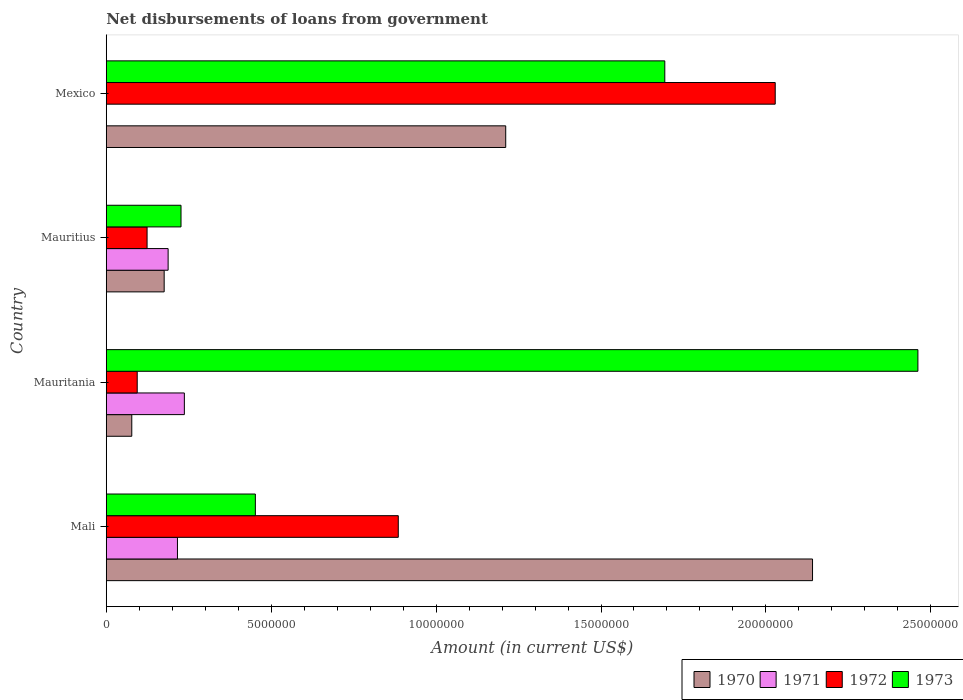How many different coloured bars are there?
Your answer should be compact. 4. Are the number of bars on each tick of the Y-axis equal?
Provide a succinct answer. No. How many bars are there on the 3rd tick from the top?
Ensure brevity in your answer.  4. How many bars are there on the 1st tick from the bottom?
Give a very brief answer. 4. What is the label of the 1st group of bars from the top?
Your response must be concise. Mexico. What is the amount of loan disbursed from government in 1973 in Mauritius?
Give a very brief answer. 2.27e+06. Across all countries, what is the maximum amount of loan disbursed from government in 1971?
Ensure brevity in your answer.  2.37e+06. Across all countries, what is the minimum amount of loan disbursed from government in 1972?
Your answer should be very brief. 9.39e+05. In which country was the amount of loan disbursed from government in 1972 maximum?
Your answer should be very brief. Mexico. What is the total amount of loan disbursed from government in 1973 in the graph?
Offer a terse response. 4.83e+07. What is the difference between the amount of loan disbursed from government in 1972 in Mauritania and that in Mexico?
Your response must be concise. -1.93e+07. What is the difference between the amount of loan disbursed from government in 1973 in Mauritania and the amount of loan disbursed from government in 1970 in Mexico?
Provide a succinct answer. 1.25e+07. What is the average amount of loan disbursed from government in 1973 per country?
Provide a succinct answer. 1.21e+07. What is the difference between the amount of loan disbursed from government in 1973 and amount of loan disbursed from government in 1972 in Mexico?
Give a very brief answer. -3.35e+06. What is the ratio of the amount of loan disbursed from government in 1972 in Mali to that in Mauritius?
Make the answer very short. 7.15. What is the difference between the highest and the second highest amount of loan disbursed from government in 1973?
Your answer should be compact. 7.67e+06. What is the difference between the highest and the lowest amount of loan disbursed from government in 1972?
Your response must be concise. 1.93e+07. In how many countries, is the amount of loan disbursed from government in 1973 greater than the average amount of loan disbursed from government in 1973 taken over all countries?
Offer a very short reply. 2. Is the sum of the amount of loan disbursed from government in 1972 in Mauritania and Mauritius greater than the maximum amount of loan disbursed from government in 1971 across all countries?
Make the answer very short. No. Is it the case that in every country, the sum of the amount of loan disbursed from government in 1970 and amount of loan disbursed from government in 1973 is greater than the amount of loan disbursed from government in 1971?
Offer a terse response. Yes. Are all the bars in the graph horizontal?
Provide a short and direct response. Yes. Are the values on the major ticks of X-axis written in scientific E-notation?
Provide a short and direct response. No. Does the graph contain grids?
Offer a very short reply. No. Where does the legend appear in the graph?
Provide a succinct answer. Bottom right. How many legend labels are there?
Provide a succinct answer. 4. How are the legend labels stacked?
Offer a terse response. Horizontal. What is the title of the graph?
Keep it short and to the point. Net disbursements of loans from government. Does "2012" appear as one of the legend labels in the graph?
Your answer should be compact. No. What is the Amount (in current US$) in 1970 in Mali?
Keep it short and to the point. 2.14e+07. What is the Amount (in current US$) in 1971 in Mali?
Give a very brief answer. 2.16e+06. What is the Amount (in current US$) in 1972 in Mali?
Give a very brief answer. 8.85e+06. What is the Amount (in current US$) of 1973 in Mali?
Provide a short and direct response. 4.52e+06. What is the Amount (in current US$) of 1970 in Mauritania?
Offer a terse response. 7.74e+05. What is the Amount (in current US$) of 1971 in Mauritania?
Make the answer very short. 2.37e+06. What is the Amount (in current US$) of 1972 in Mauritania?
Your answer should be compact. 9.39e+05. What is the Amount (in current US$) in 1973 in Mauritania?
Make the answer very short. 2.46e+07. What is the Amount (in current US$) in 1970 in Mauritius?
Make the answer very short. 1.76e+06. What is the Amount (in current US$) of 1971 in Mauritius?
Your answer should be very brief. 1.88e+06. What is the Amount (in current US$) in 1972 in Mauritius?
Give a very brief answer. 1.24e+06. What is the Amount (in current US$) of 1973 in Mauritius?
Give a very brief answer. 2.27e+06. What is the Amount (in current US$) in 1970 in Mexico?
Your answer should be very brief. 1.21e+07. What is the Amount (in current US$) in 1971 in Mexico?
Your response must be concise. 0. What is the Amount (in current US$) in 1972 in Mexico?
Offer a terse response. 2.03e+07. What is the Amount (in current US$) of 1973 in Mexico?
Provide a succinct answer. 1.69e+07. Across all countries, what is the maximum Amount (in current US$) in 1970?
Make the answer very short. 2.14e+07. Across all countries, what is the maximum Amount (in current US$) of 1971?
Your answer should be very brief. 2.37e+06. Across all countries, what is the maximum Amount (in current US$) of 1972?
Make the answer very short. 2.03e+07. Across all countries, what is the maximum Amount (in current US$) in 1973?
Keep it short and to the point. 2.46e+07. Across all countries, what is the minimum Amount (in current US$) in 1970?
Your response must be concise. 7.74e+05. Across all countries, what is the minimum Amount (in current US$) of 1971?
Provide a short and direct response. 0. Across all countries, what is the minimum Amount (in current US$) of 1972?
Your answer should be very brief. 9.39e+05. Across all countries, what is the minimum Amount (in current US$) of 1973?
Make the answer very short. 2.27e+06. What is the total Amount (in current US$) in 1970 in the graph?
Give a very brief answer. 3.61e+07. What is the total Amount (in current US$) in 1971 in the graph?
Give a very brief answer. 6.40e+06. What is the total Amount (in current US$) in 1972 in the graph?
Ensure brevity in your answer.  3.13e+07. What is the total Amount (in current US$) of 1973 in the graph?
Offer a very short reply. 4.83e+07. What is the difference between the Amount (in current US$) of 1970 in Mali and that in Mauritania?
Your answer should be very brief. 2.06e+07. What is the difference between the Amount (in current US$) in 1971 in Mali and that in Mauritania?
Keep it short and to the point. -2.09e+05. What is the difference between the Amount (in current US$) in 1972 in Mali and that in Mauritania?
Give a very brief answer. 7.92e+06. What is the difference between the Amount (in current US$) in 1973 in Mali and that in Mauritania?
Provide a short and direct response. -2.01e+07. What is the difference between the Amount (in current US$) in 1970 in Mali and that in Mauritius?
Keep it short and to the point. 1.97e+07. What is the difference between the Amount (in current US$) in 1971 in Mali and that in Mauritius?
Offer a terse response. 2.83e+05. What is the difference between the Amount (in current US$) in 1972 in Mali and that in Mauritius?
Give a very brief answer. 7.62e+06. What is the difference between the Amount (in current US$) in 1973 in Mali and that in Mauritius?
Provide a succinct answer. 2.25e+06. What is the difference between the Amount (in current US$) in 1970 in Mali and that in Mexico?
Offer a terse response. 9.30e+06. What is the difference between the Amount (in current US$) of 1972 in Mali and that in Mexico?
Provide a short and direct response. -1.14e+07. What is the difference between the Amount (in current US$) in 1973 in Mali and that in Mexico?
Offer a very short reply. -1.24e+07. What is the difference between the Amount (in current US$) of 1970 in Mauritania and that in Mauritius?
Ensure brevity in your answer.  -9.82e+05. What is the difference between the Amount (in current US$) of 1971 in Mauritania and that in Mauritius?
Give a very brief answer. 4.92e+05. What is the difference between the Amount (in current US$) of 1972 in Mauritania and that in Mauritius?
Offer a terse response. -2.99e+05. What is the difference between the Amount (in current US$) in 1973 in Mauritania and that in Mauritius?
Your answer should be compact. 2.23e+07. What is the difference between the Amount (in current US$) of 1970 in Mauritania and that in Mexico?
Offer a very short reply. -1.13e+07. What is the difference between the Amount (in current US$) in 1972 in Mauritania and that in Mexico?
Provide a short and direct response. -1.93e+07. What is the difference between the Amount (in current US$) of 1973 in Mauritania and that in Mexico?
Your answer should be very brief. 7.67e+06. What is the difference between the Amount (in current US$) of 1970 in Mauritius and that in Mexico?
Your response must be concise. -1.04e+07. What is the difference between the Amount (in current US$) of 1972 in Mauritius and that in Mexico?
Make the answer very short. -1.90e+07. What is the difference between the Amount (in current US$) in 1973 in Mauritius and that in Mexico?
Your response must be concise. -1.47e+07. What is the difference between the Amount (in current US$) in 1970 in Mali and the Amount (in current US$) in 1971 in Mauritania?
Provide a short and direct response. 1.90e+07. What is the difference between the Amount (in current US$) in 1970 in Mali and the Amount (in current US$) in 1972 in Mauritania?
Provide a succinct answer. 2.05e+07. What is the difference between the Amount (in current US$) of 1970 in Mali and the Amount (in current US$) of 1973 in Mauritania?
Provide a succinct answer. -3.20e+06. What is the difference between the Amount (in current US$) of 1971 in Mali and the Amount (in current US$) of 1972 in Mauritania?
Your answer should be compact. 1.22e+06. What is the difference between the Amount (in current US$) of 1971 in Mali and the Amount (in current US$) of 1973 in Mauritania?
Your response must be concise. -2.24e+07. What is the difference between the Amount (in current US$) in 1972 in Mali and the Amount (in current US$) in 1973 in Mauritania?
Provide a succinct answer. -1.58e+07. What is the difference between the Amount (in current US$) in 1970 in Mali and the Amount (in current US$) in 1971 in Mauritius?
Provide a succinct answer. 1.95e+07. What is the difference between the Amount (in current US$) in 1970 in Mali and the Amount (in current US$) in 1972 in Mauritius?
Provide a succinct answer. 2.02e+07. What is the difference between the Amount (in current US$) in 1970 in Mali and the Amount (in current US$) in 1973 in Mauritius?
Provide a succinct answer. 1.91e+07. What is the difference between the Amount (in current US$) of 1971 in Mali and the Amount (in current US$) of 1972 in Mauritius?
Keep it short and to the point. 9.21e+05. What is the difference between the Amount (in current US$) in 1971 in Mali and the Amount (in current US$) in 1973 in Mauritius?
Your response must be concise. -1.08e+05. What is the difference between the Amount (in current US$) in 1972 in Mali and the Amount (in current US$) in 1973 in Mauritius?
Make the answer very short. 6.59e+06. What is the difference between the Amount (in current US$) of 1970 in Mali and the Amount (in current US$) of 1972 in Mexico?
Give a very brief answer. 1.13e+06. What is the difference between the Amount (in current US$) of 1970 in Mali and the Amount (in current US$) of 1973 in Mexico?
Keep it short and to the point. 4.48e+06. What is the difference between the Amount (in current US$) in 1971 in Mali and the Amount (in current US$) in 1972 in Mexico?
Ensure brevity in your answer.  -1.81e+07. What is the difference between the Amount (in current US$) of 1971 in Mali and the Amount (in current US$) of 1973 in Mexico?
Keep it short and to the point. -1.48e+07. What is the difference between the Amount (in current US$) of 1972 in Mali and the Amount (in current US$) of 1973 in Mexico?
Provide a short and direct response. -8.08e+06. What is the difference between the Amount (in current US$) in 1970 in Mauritania and the Amount (in current US$) in 1971 in Mauritius?
Offer a very short reply. -1.10e+06. What is the difference between the Amount (in current US$) in 1970 in Mauritania and the Amount (in current US$) in 1972 in Mauritius?
Offer a very short reply. -4.64e+05. What is the difference between the Amount (in current US$) in 1970 in Mauritania and the Amount (in current US$) in 1973 in Mauritius?
Offer a very short reply. -1.49e+06. What is the difference between the Amount (in current US$) in 1971 in Mauritania and the Amount (in current US$) in 1972 in Mauritius?
Provide a succinct answer. 1.13e+06. What is the difference between the Amount (in current US$) in 1971 in Mauritania and the Amount (in current US$) in 1973 in Mauritius?
Your answer should be compact. 1.01e+05. What is the difference between the Amount (in current US$) of 1972 in Mauritania and the Amount (in current US$) of 1973 in Mauritius?
Provide a short and direct response. -1.33e+06. What is the difference between the Amount (in current US$) of 1970 in Mauritania and the Amount (in current US$) of 1972 in Mexico?
Your answer should be very brief. -1.95e+07. What is the difference between the Amount (in current US$) of 1970 in Mauritania and the Amount (in current US$) of 1973 in Mexico?
Offer a terse response. -1.62e+07. What is the difference between the Amount (in current US$) of 1971 in Mauritania and the Amount (in current US$) of 1972 in Mexico?
Make the answer very short. -1.79e+07. What is the difference between the Amount (in current US$) of 1971 in Mauritania and the Amount (in current US$) of 1973 in Mexico?
Make the answer very short. -1.46e+07. What is the difference between the Amount (in current US$) of 1972 in Mauritania and the Amount (in current US$) of 1973 in Mexico?
Keep it short and to the point. -1.60e+07. What is the difference between the Amount (in current US$) in 1970 in Mauritius and the Amount (in current US$) in 1972 in Mexico?
Your response must be concise. -1.85e+07. What is the difference between the Amount (in current US$) in 1970 in Mauritius and the Amount (in current US$) in 1973 in Mexico?
Ensure brevity in your answer.  -1.52e+07. What is the difference between the Amount (in current US$) in 1971 in Mauritius and the Amount (in current US$) in 1972 in Mexico?
Your answer should be very brief. -1.84e+07. What is the difference between the Amount (in current US$) in 1971 in Mauritius and the Amount (in current US$) in 1973 in Mexico?
Ensure brevity in your answer.  -1.51e+07. What is the difference between the Amount (in current US$) of 1972 in Mauritius and the Amount (in current US$) of 1973 in Mexico?
Your answer should be compact. -1.57e+07. What is the average Amount (in current US$) in 1970 per country?
Give a very brief answer. 9.01e+06. What is the average Amount (in current US$) of 1971 per country?
Provide a short and direct response. 1.60e+06. What is the average Amount (in current US$) of 1972 per country?
Offer a terse response. 7.83e+06. What is the average Amount (in current US$) of 1973 per country?
Offer a terse response. 1.21e+07. What is the difference between the Amount (in current US$) in 1970 and Amount (in current US$) in 1971 in Mali?
Give a very brief answer. 1.93e+07. What is the difference between the Amount (in current US$) in 1970 and Amount (in current US$) in 1972 in Mali?
Your response must be concise. 1.26e+07. What is the difference between the Amount (in current US$) of 1970 and Amount (in current US$) of 1973 in Mali?
Your response must be concise. 1.69e+07. What is the difference between the Amount (in current US$) of 1971 and Amount (in current US$) of 1972 in Mali?
Your response must be concise. -6.70e+06. What is the difference between the Amount (in current US$) of 1971 and Amount (in current US$) of 1973 in Mali?
Your answer should be very brief. -2.36e+06. What is the difference between the Amount (in current US$) of 1972 and Amount (in current US$) of 1973 in Mali?
Your response must be concise. 4.33e+06. What is the difference between the Amount (in current US$) of 1970 and Amount (in current US$) of 1971 in Mauritania?
Your response must be concise. -1.59e+06. What is the difference between the Amount (in current US$) in 1970 and Amount (in current US$) in 1972 in Mauritania?
Your answer should be very brief. -1.65e+05. What is the difference between the Amount (in current US$) of 1970 and Amount (in current US$) of 1973 in Mauritania?
Ensure brevity in your answer.  -2.38e+07. What is the difference between the Amount (in current US$) of 1971 and Amount (in current US$) of 1972 in Mauritania?
Provide a succinct answer. 1.43e+06. What is the difference between the Amount (in current US$) of 1971 and Amount (in current US$) of 1973 in Mauritania?
Your response must be concise. -2.22e+07. What is the difference between the Amount (in current US$) in 1972 and Amount (in current US$) in 1973 in Mauritania?
Your answer should be compact. -2.37e+07. What is the difference between the Amount (in current US$) in 1970 and Amount (in current US$) in 1972 in Mauritius?
Make the answer very short. 5.18e+05. What is the difference between the Amount (in current US$) of 1970 and Amount (in current US$) of 1973 in Mauritius?
Offer a very short reply. -5.11e+05. What is the difference between the Amount (in current US$) in 1971 and Amount (in current US$) in 1972 in Mauritius?
Your response must be concise. 6.38e+05. What is the difference between the Amount (in current US$) of 1971 and Amount (in current US$) of 1973 in Mauritius?
Give a very brief answer. -3.91e+05. What is the difference between the Amount (in current US$) in 1972 and Amount (in current US$) in 1973 in Mauritius?
Your answer should be very brief. -1.03e+06. What is the difference between the Amount (in current US$) in 1970 and Amount (in current US$) in 1972 in Mexico?
Keep it short and to the point. -8.17e+06. What is the difference between the Amount (in current US$) of 1970 and Amount (in current US$) of 1973 in Mexico?
Your answer should be compact. -4.82e+06. What is the difference between the Amount (in current US$) of 1972 and Amount (in current US$) of 1973 in Mexico?
Offer a very short reply. 3.35e+06. What is the ratio of the Amount (in current US$) in 1970 in Mali to that in Mauritania?
Your answer should be compact. 27.67. What is the ratio of the Amount (in current US$) of 1971 in Mali to that in Mauritania?
Your answer should be very brief. 0.91. What is the ratio of the Amount (in current US$) in 1972 in Mali to that in Mauritania?
Offer a terse response. 9.43. What is the ratio of the Amount (in current US$) of 1973 in Mali to that in Mauritania?
Your response must be concise. 0.18. What is the ratio of the Amount (in current US$) of 1970 in Mali to that in Mauritius?
Your response must be concise. 12.19. What is the ratio of the Amount (in current US$) in 1971 in Mali to that in Mauritius?
Your response must be concise. 1.15. What is the ratio of the Amount (in current US$) in 1972 in Mali to that in Mauritius?
Offer a very short reply. 7.15. What is the ratio of the Amount (in current US$) in 1973 in Mali to that in Mauritius?
Offer a terse response. 1.99. What is the ratio of the Amount (in current US$) in 1970 in Mali to that in Mexico?
Give a very brief answer. 1.77. What is the ratio of the Amount (in current US$) of 1972 in Mali to that in Mexico?
Make the answer very short. 0.44. What is the ratio of the Amount (in current US$) of 1973 in Mali to that in Mexico?
Provide a short and direct response. 0.27. What is the ratio of the Amount (in current US$) in 1970 in Mauritania to that in Mauritius?
Provide a succinct answer. 0.44. What is the ratio of the Amount (in current US$) of 1971 in Mauritania to that in Mauritius?
Provide a succinct answer. 1.26. What is the ratio of the Amount (in current US$) in 1972 in Mauritania to that in Mauritius?
Make the answer very short. 0.76. What is the ratio of the Amount (in current US$) in 1973 in Mauritania to that in Mauritius?
Offer a terse response. 10.85. What is the ratio of the Amount (in current US$) of 1970 in Mauritania to that in Mexico?
Your answer should be very brief. 0.06. What is the ratio of the Amount (in current US$) of 1972 in Mauritania to that in Mexico?
Your answer should be very brief. 0.05. What is the ratio of the Amount (in current US$) of 1973 in Mauritania to that in Mexico?
Your answer should be very brief. 1.45. What is the ratio of the Amount (in current US$) in 1970 in Mauritius to that in Mexico?
Ensure brevity in your answer.  0.14. What is the ratio of the Amount (in current US$) of 1972 in Mauritius to that in Mexico?
Give a very brief answer. 0.06. What is the ratio of the Amount (in current US$) in 1973 in Mauritius to that in Mexico?
Provide a succinct answer. 0.13. What is the difference between the highest and the second highest Amount (in current US$) in 1970?
Make the answer very short. 9.30e+06. What is the difference between the highest and the second highest Amount (in current US$) in 1971?
Provide a succinct answer. 2.09e+05. What is the difference between the highest and the second highest Amount (in current US$) of 1972?
Offer a very short reply. 1.14e+07. What is the difference between the highest and the second highest Amount (in current US$) in 1973?
Keep it short and to the point. 7.67e+06. What is the difference between the highest and the lowest Amount (in current US$) of 1970?
Make the answer very short. 2.06e+07. What is the difference between the highest and the lowest Amount (in current US$) of 1971?
Provide a succinct answer. 2.37e+06. What is the difference between the highest and the lowest Amount (in current US$) in 1972?
Keep it short and to the point. 1.93e+07. What is the difference between the highest and the lowest Amount (in current US$) of 1973?
Your response must be concise. 2.23e+07. 